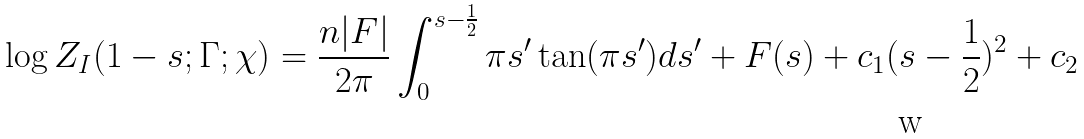<formula> <loc_0><loc_0><loc_500><loc_500>\log Z _ { I } ( 1 - s ; \Gamma ; \chi ) = \frac { n | F | } { 2 \pi } \int _ { 0 } ^ { s - \frac { 1 } { 2 } } \pi s ^ { \prime } \tan ( \pi s ^ { \prime } ) d s ^ { \prime } + F ( s ) + c _ { 1 } ( s - \frac { 1 } { 2 } ) ^ { 2 } + c _ { 2 }</formula> 